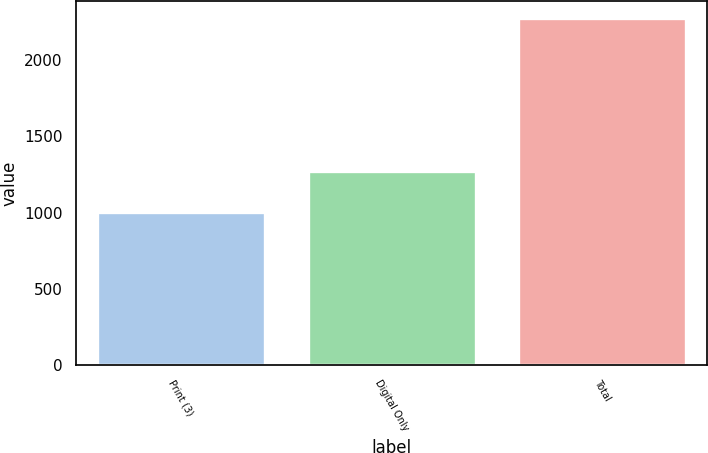<chart> <loc_0><loc_0><loc_500><loc_500><bar_chart><fcel>Print (3)<fcel>Digital Only<fcel>Total<nl><fcel>1007<fcel>1270<fcel>2277<nl></chart> 